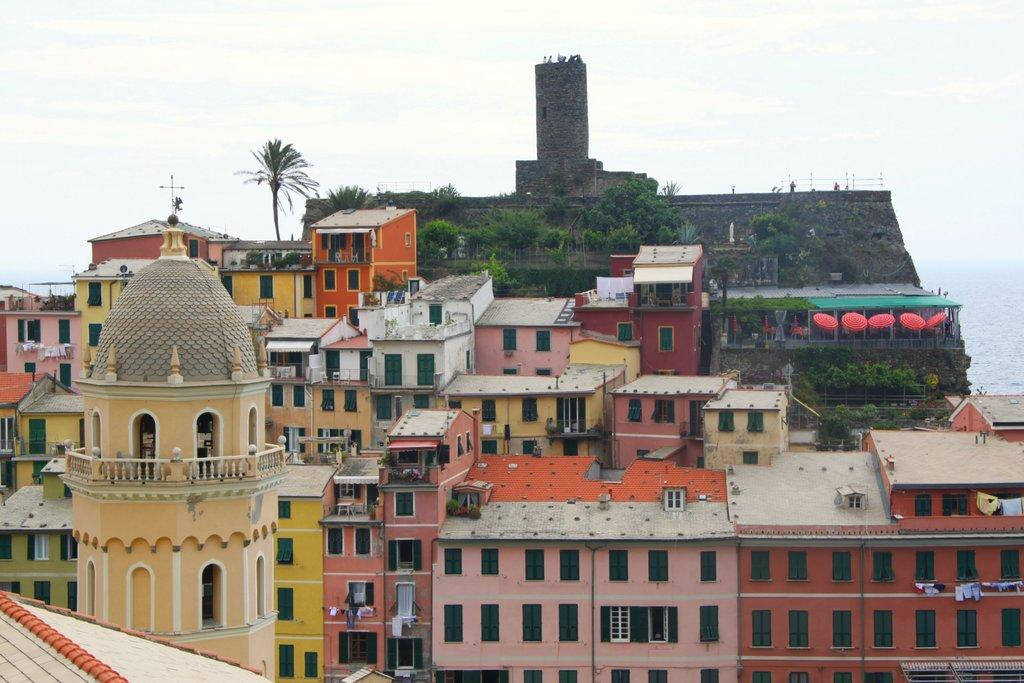What type of structures are present in the image? There are buildings in the image. Can you describe the appearance of the buildings? The buildings are of different colors. What is the condition of the sky in the image? The sky is clear in the image. How many cherries can be seen growing on the buildings in the image? There are no cherries present in the image, as it features buildings and a clear sky. What type of tool is being used to clean the space around the buildings in the image? There is no tool or activity related to cleaning or space maintenance depicted in the image. 